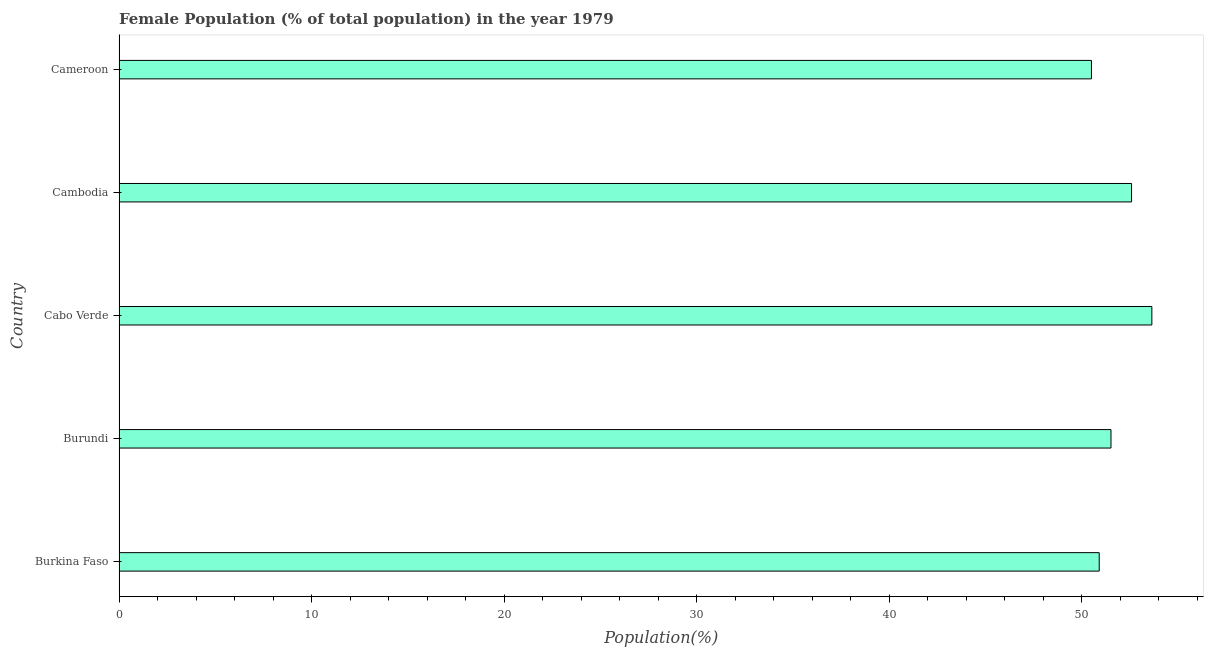What is the title of the graph?
Offer a very short reply. Female Population (% of total population) in the year 1979. What is the label or title of the X-axis?
Offer a very short reply. Population(%). What is the label or title of the Y-axis?
Give a very brief answer. Country. What is the female population in Burkina Faso?
Your answer should be compact. 50.91. Across all countries, what is the maximum female population?
Keep it short and to the point. 53.65. Across all countries, what is the minimum female population?
Offer a terse response. 50.51. In which country was the female population maximum?
Make the answer very short. Cabo Verde. In which country was the female population minimum?
Keep it short and to the point. Cameroon. What is the sum of the female population?
Ensure brevity in your answer.  259.19. What is the difference between the female population in Burundi and Cameroon?
Provide a short and direct response. 1.01. What is the average female population per country?
Make the answer very short. 51.84. What is the median female population?
Your response must be concise. 51.52. In how many countries, is the female population greater than 14 %?
Offer a very short reply. 5. What is the ratio of the female population in Cambodia to that in Cameroon?
Ensure brevity in your answer.  1.04. Is the difference between the female population in Cabo Verde and Cameroon greater than the difference between any two countries?
Provide a succinct answer. Yes. What is the difference between the highest and the second highest female population?
Offer a terse response. 1.05. What is the difference between the highest and the lowest female population?
Keep it short and to the point. 3.14. How many countries are there in the graph?
Your response must be concise. 5. What is the difference between two consecutive major ticks on the X-axis?
Your response must be concise. 10. Are the values on the major ticks of X-axis written in scientific E-notation?
Keep it short and to the point. No. What is the Population(%) of Burkina Faso?
Keep it short and to the point. 50.91. What is the Population(%) of Burundi?
Ensure brevity in your answer.  51.52. What is the Population(%) in Cabo Verde?
Ensure brevity in your answer.  53.65. What is the Population(%) in Cambodia?
Your answer should be compact. 52.59. What is the Population(%) of Cameroon?
Your answer should be very brief. 50.51. What is the difference between the Population(%) in Burkina Faso and Burundi?
Provide a succinct answer. -0.61. What is the difference between the Population(%) in Burkina Faso and Cabo Verde?
Your answer should be very brief. -2.73. What is the difference between the Population(%) in Burkina Faso and Cambodia?
Keep it short and to the point. -1.68. What is the difference between the Population(%) in Burkina Faso and Cameroon?
Your response must be concise. 0.4. What is the difference between the Population(%) in Burundi and Cabo Verde?
Your response must be concise. -2.12. What is the difference between the Population(%) in Burundi and Cambodia?
Give a very brief answer. -1.07. What is the difference between the Population(%) in Burundi and Cameroon?
Provide a succinct answer. 1.01. What is the difference between the Population(%) in Cabo Verde and Cambodia?
Offer a very short reply. 1.06. What is the difference between the Population(%) in Cabo Verde and Cameroon?
Provide a succinct answer. 3.14. What is the difference between the Population(%) in Cambodia and Cameroon?
Make the answer very short. 2.08. What is the ratio of the Population(%) in Burkina Faso to that in Burundi?
Make the answer very short. 0.99. What is the ratio of the Population(%) in Burkina Faso to that in Cabo Verde?
Provide a short and direct response. 0.95. What is the ratio of the Population(%) in Burkina Faso to that in Cambodia?
Make the answer very short. 0.97. What is the ratio of the Population(%) in Burkina Faso to that in Cameroon?
Your response must be concise. 1.01. What is the ratio of the Population(%) in Burundi to that in Cabo Verde?
Make the answer very short. 0.96. What is the ratio of the Population(%) in Burundi to that in Cambodia?
Provide a short and direct response. 0.98. What is the ratio of the Population(%) in Burundi to that in Cameroon?
Offer a terse response. 1.02. What is the ratio of the Population(%) in Cabo Verde to that in Cambodia?
Keep it short and to the point. 1.02. What is the ratio of the Population(%) in Cabo Verde to that in Cameroon?
Offer a terse response. 1.06. What is the ratio of the Population(%) in Cambodia to that in Cameroon?
Your answer should be compact. 1.04. 